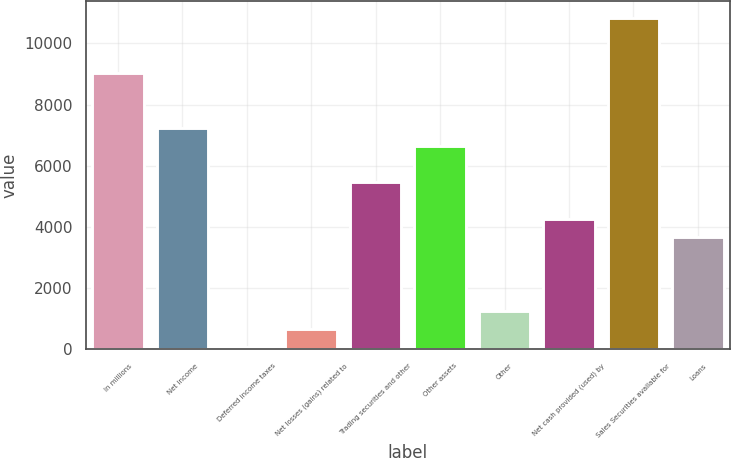Convert chart to OTSL. <chart><loc_0><loc_0><loc_500><loc_500><bar_chart><fcel>In millions<fcel>Net income<fcel>Deferred income taxes<fcel>Net losses (gains) related to<fcel>Trading securities and other<fcel>Other assets<fcel>Other<fcel>Net cash provided (used) by<fcel>Sales Securities available for<fcel>Loans<nl><fcel>9045<fcel>7251.6<fcel>78<fcel>675.8<fcel>5458.2<fcel>6653.8<fcel>1273.6<fcel>4262.6<fcel>10838.4<fcel>3664.8<nl></chart> 